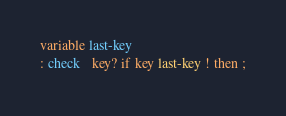Convert code to text. <code><loc_0><loc_0><loc_500><loc_500><_Forth_>variable last-key
: check   key? if key last-key ! then ;
</code> 